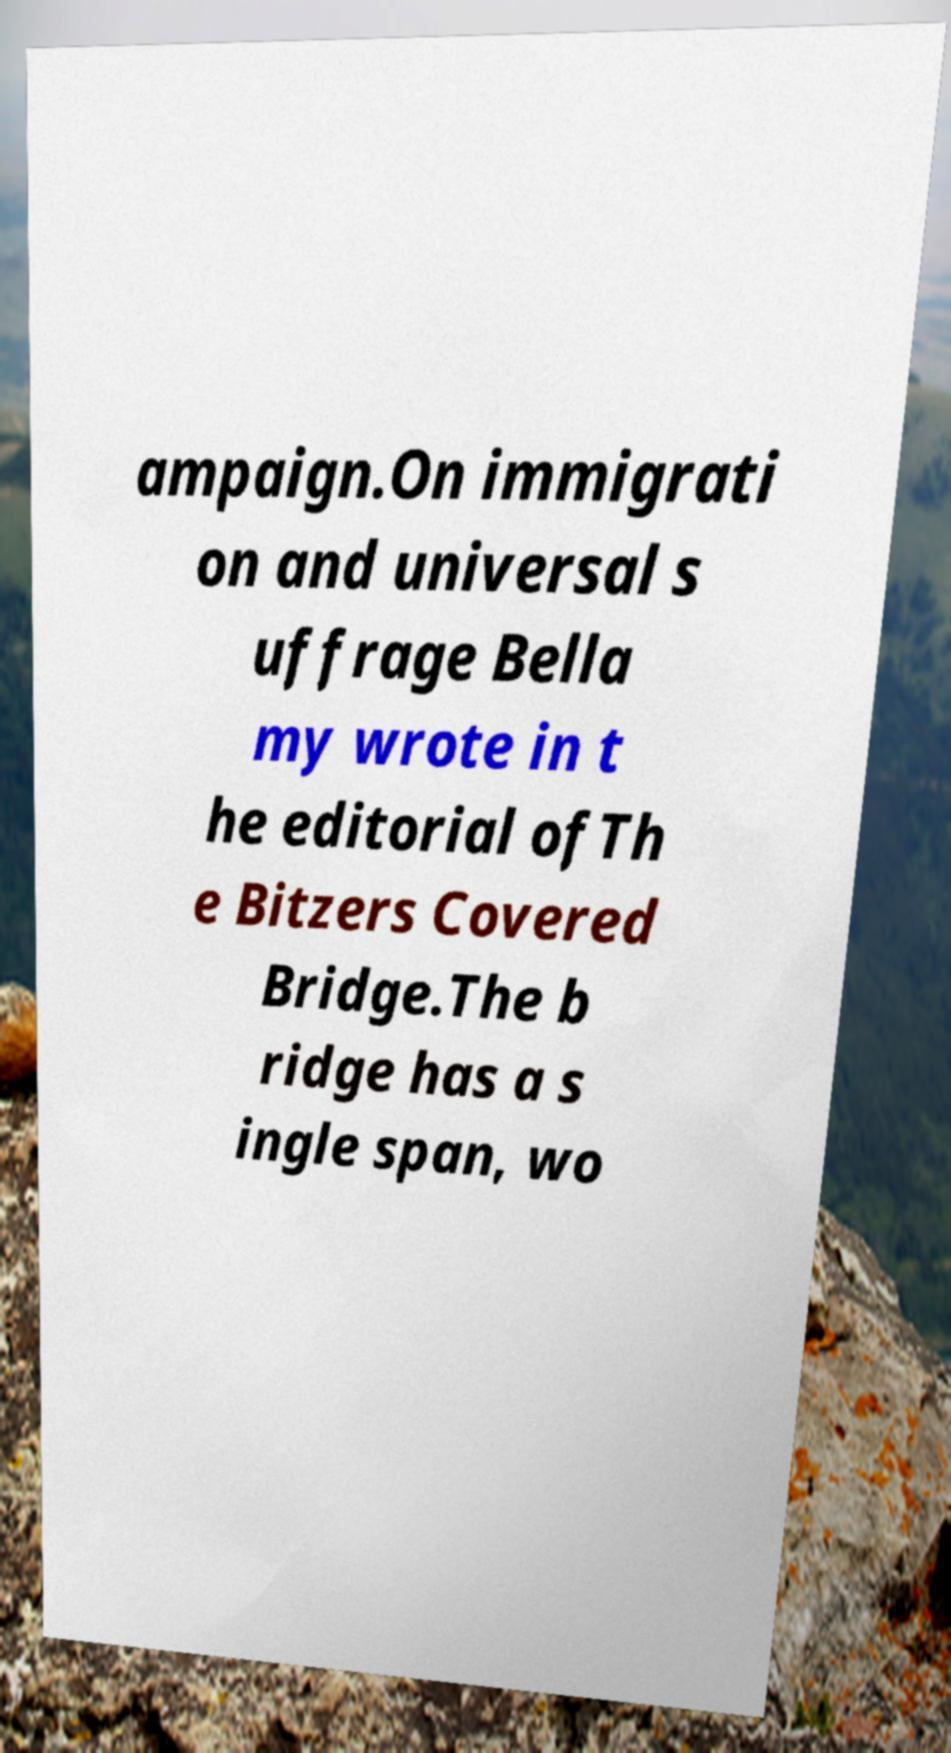For documentation purposes, I need the text within this image transcribed. Could you provide that? ampaign.On immigrati on and universal s uffrage Bella my wrote in t he editorial ofTh e Bitzers Covered Bridge.The b ridge has a s ingle span, wo 